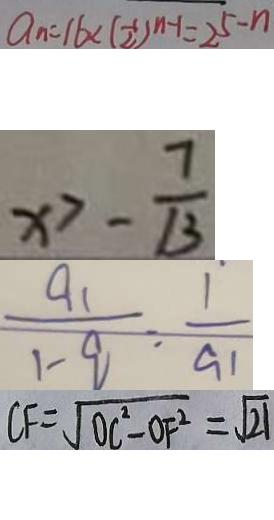<formula> <loc_0><loc_0><loc_500><loc_500>a _ { n } = 1 6 < ( \frac { 1 } { 2 } ) ^ { n - 1 } = 2 ^ { 5 } - n 
 x > - \frac { 7 } { 1 3 } 
 \frac { a _ { 1 } } { 1 - q } = \frac { 1 } { a _ { 1 } } 
 C F = \sqrt { O C ^ { 2 } - O F ^ { 2 } } = \sqrt { 2 1 }</formula> 